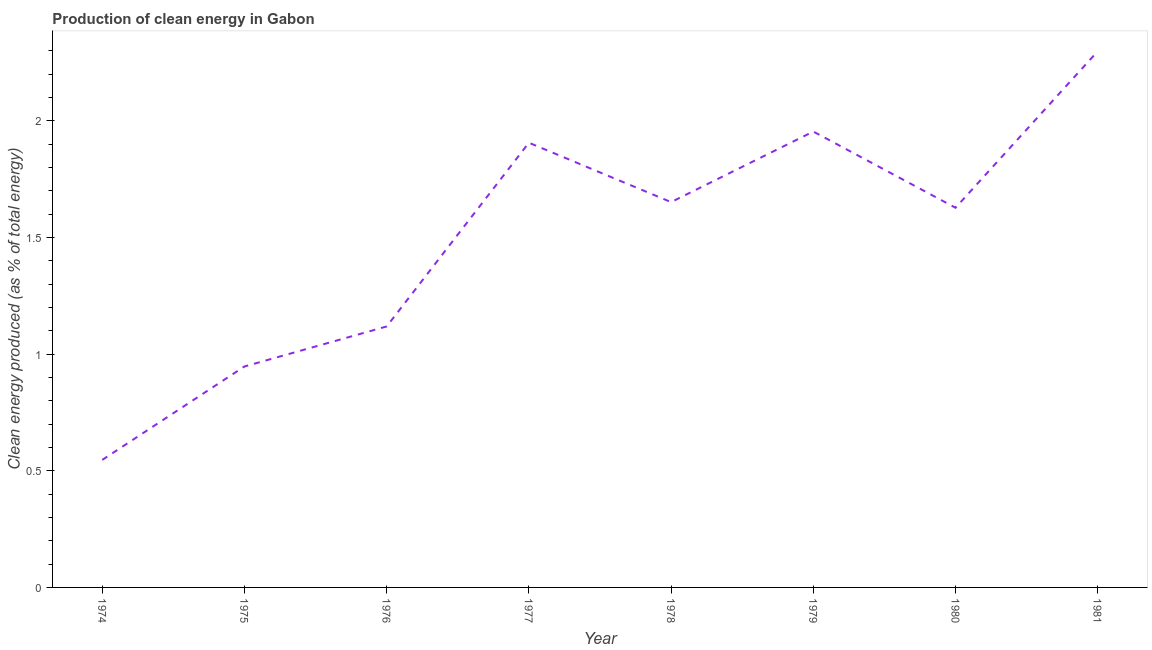What is the production of clean energy in 1976?
Keep it short and to the point. 1.12. Across all years, what is the maximum production of clean energy?
Your answer should be very brief. 2.3. Across all years, what is the minimum production of clean energy?
Ensure brevity in your answer.  0.55. In which year was the production of clean energy maximum?
Offer a terse response. 1981. In which year was the production of clean energy minimum?
Make the answer very short. 1974. What is the sum of the production of clean energy?
Your answer should be compact. 12.05. What is the difference between the production of clean energy in 1979 and 1981?
Make the answer very short. -0.34. What is the average production of clean energy per year?
Give a very brief answer. 1.51. What is the median production of clean energy?
Your answer should be very brief. 1.64. In how many years, is the production of clean energy greater than 1.7 %?
Give a very brief answer. 3. Do a majority of the years between 1979 and 1974 (inclusive) have production of clean energy greater than 0.7 %?
Provide a short and direct response. Yes. What is the ratio of the production of clean energy in 1974 to that in 1980?
Your response must be concise. 0.34. Is the production of clean energy in 1980 less than that in 1981?
Provide a short and direct response. Yes. Is the difference between the production of clean energy in 1974 and 1976 greater than the difference between any two years?
Provide a short and direct response. No. What is the difference between the highest and the second highest production of clean energy?
Make the answer very short. 0.34. What is the difference between the highest and the lowest production of clean energy?
Your answer should be very brief. 1.75. How many years are there in the graph?
Provide a short and direct response. 8. What is the difference between two consecutive major ticks on the Y-axis?
Your response must be concise. 0.5. What is the title of the graph?
Your answer should be very brief. Production of clean energy in Gabon. What is the label or title of the Y-axis?
Ensure brevity in your answer.  Clean energy produced (as % of total energy). What is the Clean energy produced (as % of total energy) of 1974?
Offer a very short reply. 0.55. What is the Clean energy produced (as % of total energy) of 1975?
Offer a very short reply. 0.95. What is the Clean energy produced (as % of total energy) in 1976?
Your response must be concise. 1.12. What is the Clean energy produced (as % of total energy) of 1977?
Offer a terse response. 1.91. What is the Clean energy produced (as % of total energy) of 1978?
Make the answer very short. 1.65. What is the Clean energy produced (as % of total energy) of 1979?
Give a very brief answer. 1.95. What is the Clean energy produced (as % of total energy) of 1980?
Your response must be concise. 1.63. What is the Clean energy produced (as % of total energy) in 1981?
Offer a terse response. 2.3. What is the difference between the Clean energy produced (as % of total energy) in 1974 and 1975?
Offer a very short reply. -0.4. What is the difference between the Clean energy produced (as % of total energy) in 1974 and 1976?
Provide a succinct answer. -0.57. What is the difference between the Clean energy produced (as % of total energy) in 1974 and 1977?
Provide a succinct answer. -1.36. What is the difference between the Clean energy produced (as % of total energy) in 1974 and 1978?
Provide a succinct answer. -1.1. What is the difference between the Clean energy produced (as % of total energy) in 1974 and 1979?
Keep it short and to the point. -1.41. What is the difference between the Clean energy produced (as % of total energy) in 1974 and 1980?
Keep it short and to the point. -1.08. What is the difference between the Clean energy produced (as % of total energy) in 1974 and 1981?
Ensure brevity in your answer.  -1.75. What is the difference between the Clean energy produced (as % of total energy) in 1975 and 1976?
Give a very brief answer. -0.17. What is the difference between the Clean energy produced (as % of total energy) in 1975 and 1977?
Your response must be concise. -0.96. What is the difference between the Clean energy produced (as % of total energy) in 1975 and 1978?
Your answer should be very brief. -0.7. What is the difference between the Clean energy produced (as % of total energy) in 1975 and 1979?
Offer a terse response. -1.01. What is the difference between the Clean energy produced (as % of total energy) in 1975 and 1980?
Keep it short and to the point. -0.68. What is the difference between the Clean energy produced (as % of total energy) in 1975 and 1981?
Make the answer very short. -1.35. What is the difference between the Clean energy produced (as % of total energy) in 1976 and 1977?
Offer a very short reply. -0.79. What is the difference between the Clean energy produced (as % of total energy) in 1976 and 1978?
Keep it short and to the point. -0.53. What is the difference between the Clean energy produced (as % of total energy) in 1976 and 1979?
Your answer should be very brief. -0.84. What is the difference between the Clean energy produced (as % of total energy) in 1976 and 1980?
Your answer should be compact. -0.51. What is the difference between the Clean energy produced (as % of total energy) in 1976 and 1981?
Provide a short and direct response. -1.18. What is the difference between the Clean energy produced (as % of total energy) in 1977 and 1978?
Provide a succinct answer. 0.25. What is the difference between the Clean energy produced (as % of total energy) in 1977 and 1979?
Your response must be concise. -0.05. What is the difference between the Clean energy produced (as % of total energy) in 1977 and 1980?
Provide a succinct answer. 0.28. What is the difference between the Clean energy produced (as % of total energy) in 1977 and 1981?
Your answer should be very brief. -0.39. What is the difference between the Clean energy produced (as % of total energy) in 1978 and 1979?
Ensure brevity in your answer.  -0.3. What is the difference between the Clean energy produced (as % of total energy) in 1978 and 1980?
Offer a terse response. 0.02. What is the difference between the Clean energy produced (as % of total energy) in 1978 and 1981?
Offer a very short reply. -0.65. What is the difference between the Clean energy produced (as % of total energy) in 1979 and 1980?
Ensure brevity in your answer.  0.33. What is the difference between the Clean energy produced (as % of total energy) in 1979 and 1981?
Offer a very short reply. -0.34. What is the difference between the Clean energy produced (as % of total energy) in 1980 and 1981?
Your answer should be compact. -0.67. What is the ratio of the Clean energy produced (as % of total energy) in 1974 to that in 1975?
Your response must be concise. 0.58. What is the ratio of the Clean energy produced (as % of total energy) in 1974 to that in 1976?
Your answer should be very brief. 0.49. What is the ratio of the Clean energy produced (as % of total energy) in 1974 to that in 1977?
Ensure brevity in your answer.  0.29. What is the ratio of the Clean energy produced (as % of total energy) in 1974 to that in 1978?
Give a very brief answer. 0.33. What is the ratio of the Clean energy produced (as % of total energy) in 1974 to that in 1979?
Offer a terse response. 0.28. What is the ratio of the Clean energy produced (as % of total energy) in 1974 to that in 1980?
Your response must be concise. 0.34. What is the ratio of the Clean energy produced (as % of total energy) in 1974 to that in 1981?
Your answer should be compact. 0.24. What is the ratio of the Clean energy produced (as % of total energy) in 1975 to that in 1976?
Provide a short and direct response. 0.85. What is the ratio of the Clean energy produced (as % of total energy) in 1975 to that in 1977?
Make the answer very short. 0.5. What is the ratio of the Clean energy produced (as % of total energy) in 1975 to that in 1978?
Your answer should be compact. 0.57. What is the ratio of the Clean energy produced (as % of total energy) in 1975 to that in 1979?
Provide a short and direct response. 0.48. What is the ratio of the Clean energy produced (as % of total energy) in 1975 to that in 1980?
Give a very brief answer. 0.58. What is the ratio of the Clean energy produced (as % of total energy) in 1975 to that in 1981?
Offer a terse response. 0.41. What is the ratio of the Clean energy produced (as % of total energy) in 1976 to that in 1977?
Provide a succinct answer. 0.59. What is the ratio of the Clean energy produced (as % of total energy) in 1976 to that in 1978?
Your answer should be very brief. 0.68. What is the ratio of the Clean energy produced (as % of total energy) in 1976 to that in 1979?
Your answer should be very brief. 0.57. What is the ratio of the Clean energy produced (as % of total energy) in 1976 to that in 1980?
Give a very brief answer. 0.69. What is the ratio of the Clean energy produced (as % of total energy) in 1976 to that in 1981?
Make the answer very short. 0.49. What is the ratio of the Clean energy produced (as % of total energy) in 1977 to that in 1978?
Provide a succinct answer. 1.15. What is the ratio of the Clean energy produced (as % of total energy) in 1977 to that in 1979?
Give a very brief answer. 0.97. What is the ratio of the Clean energy produced (as % of total energy) in 1977 to that in 1980?
Offer a terse response. 1.17. What is the ratio of the Clean energy produced (as % of total energy) in 1977 to that in 1981?
Offer a terse response. 0.83. What is the ratio of the Clean energy produced (as % of total energy) in 1978 to that in 1979?
Your answer should be very brief. 0.84. What is the ratio of the Clean energy produced (as % of total energy) in 1978 to that in 1980?
Ensure brevity in your answer.  1.01. What is the ratio of the Clean energy produced (as % of total energy) in 1978 to that in 1981?
Ensure brevity in your answer.  0.72. What is the ratio of the Clean energy produced (as % of total energy) in 1979 to that in 1980?
Your answer should be very brief. 1.2. What is the ratio of the Clean energy produced (as % of total energy) in 1980 to that in 1981?
Provide a succinct answer. 0.71. 